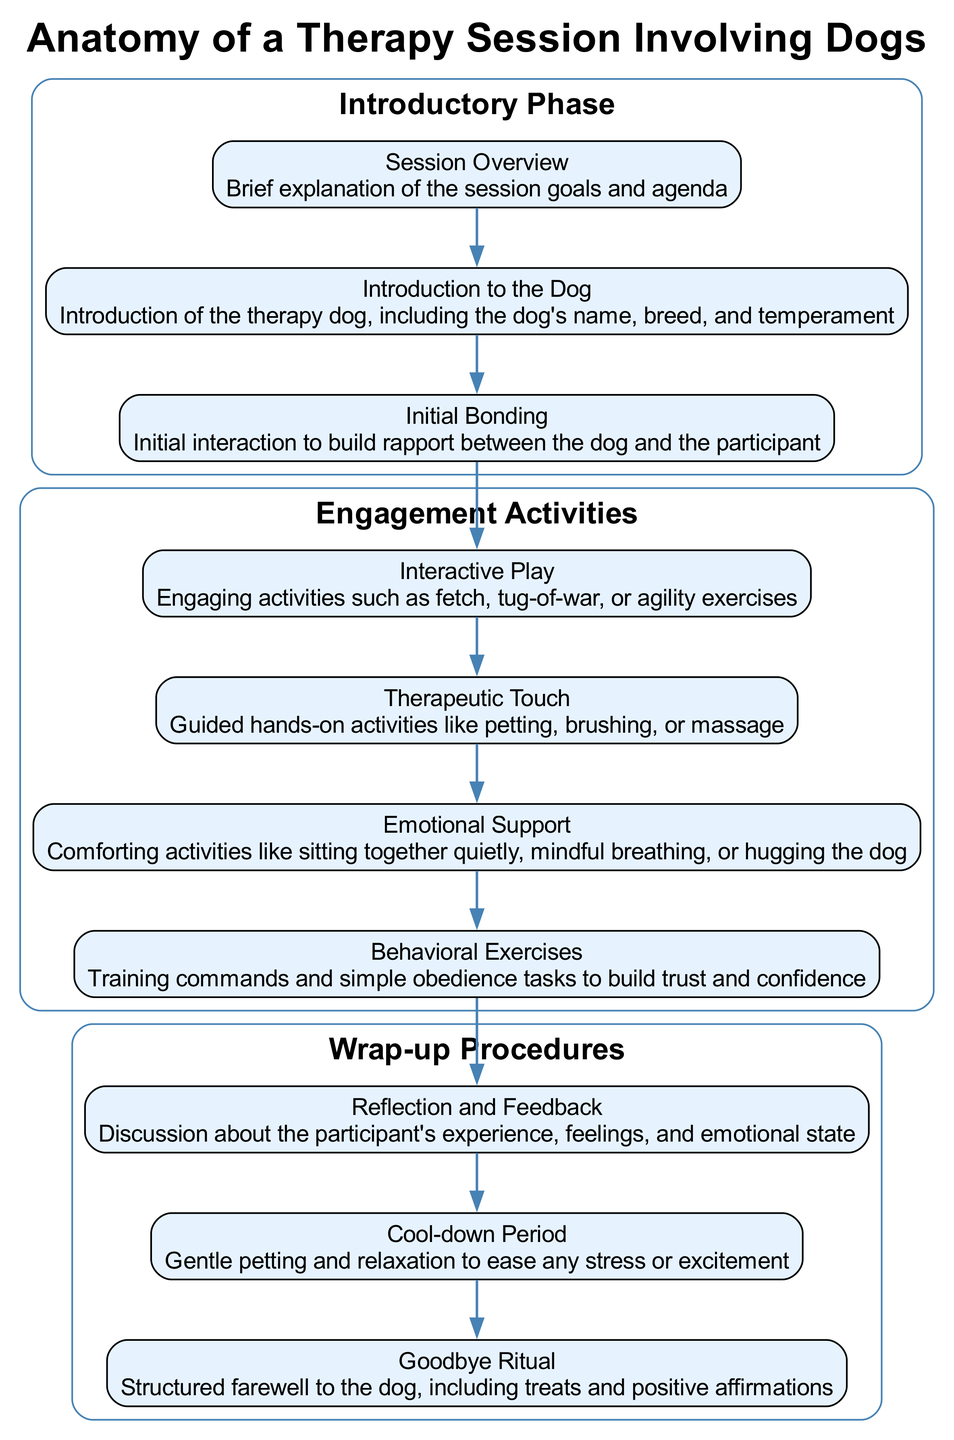What is the first element in the Introductory Phase? The first element in the Introductory Phase is "Session Overview." This can be determined by looking at the sequence of elements listed under this phase, where "Session Overview" is at the top.
Answer: Session Overview How many elements are there in the Engagement Activities phase? To find the number of elements in the Engagement Activities phase, we need to count the listed activities. There are four described activities: Interactive Play, Therapeutic Touch, Emotional Support, and Behavioral Exercises, thus totaling four elements.
Answer: 4 Which element focuses on building rapport? The element focused on building rapport is "Initial Bonding." This is explicitly stated as part of the elements under the Introductory Phase, highlighting its purpose to foster connection.
Answer: Initial Bonding What is the last element in the Wrap-up Procedures phase? The last element in the Wrap-up Procedures phase is "Goodbye Ritual." By examining the flow of elements in this phase, we can see that it comes last in the listed sequence.
Answer: Goodbye Ritual How many phases are there in total? The total number of phases can be determined by counting them. There are three phases outlined: Introductory Phase, Engagement Activities, and Wrap-up Procedures. Therefore, the answer is three phases.
Answer: 3 What is the primary focus of the Emotional Support activity? The primary focus of the Emotional Support activity is on comforting activities, which include sitting together quietly, mindful breathing, or hugging the dog. These activities aim at providing emotional comfort.
Answer: Comforting activities How are the phases connected? The phases are connected sequentially, where the last element of each phase leads to the first element of the subsequent phase. Specifically, the last element of the Introductory Phase connects to the first element of Engagement Activities. This directional flow shows how each phase transitions into the next.
Answer: Sequentially Which activity involves training commands? The activity that involves training commands is called "Behavioral Exercises." This is noted under the Engagement Activities phase, where it mentions tasks related to trust and obedience.
Answer: Behavioral Exercises 